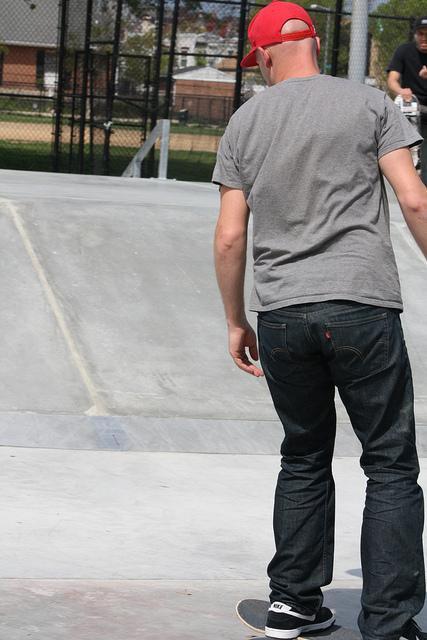How many people are there?
Give a very brief answer. 2. 